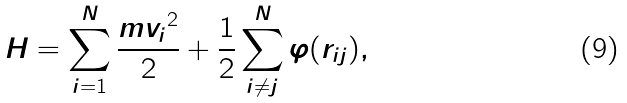<formula> <loc_0><loc_0><loc_500><loc_500>H = \sum _ { i = 1 } ^ { N } \frac { m { { v } _ { i } } ^ { 2 } } { 2 } + \frac { 1 } { 2 } \sum _ { i \ne j } ^ { N } \varphi ( r _ { i j } ) ,</formula> 